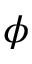Convert formula to latex. <formula><loc_0><loc_0><loc_500><loc_500>\phi</formula> 